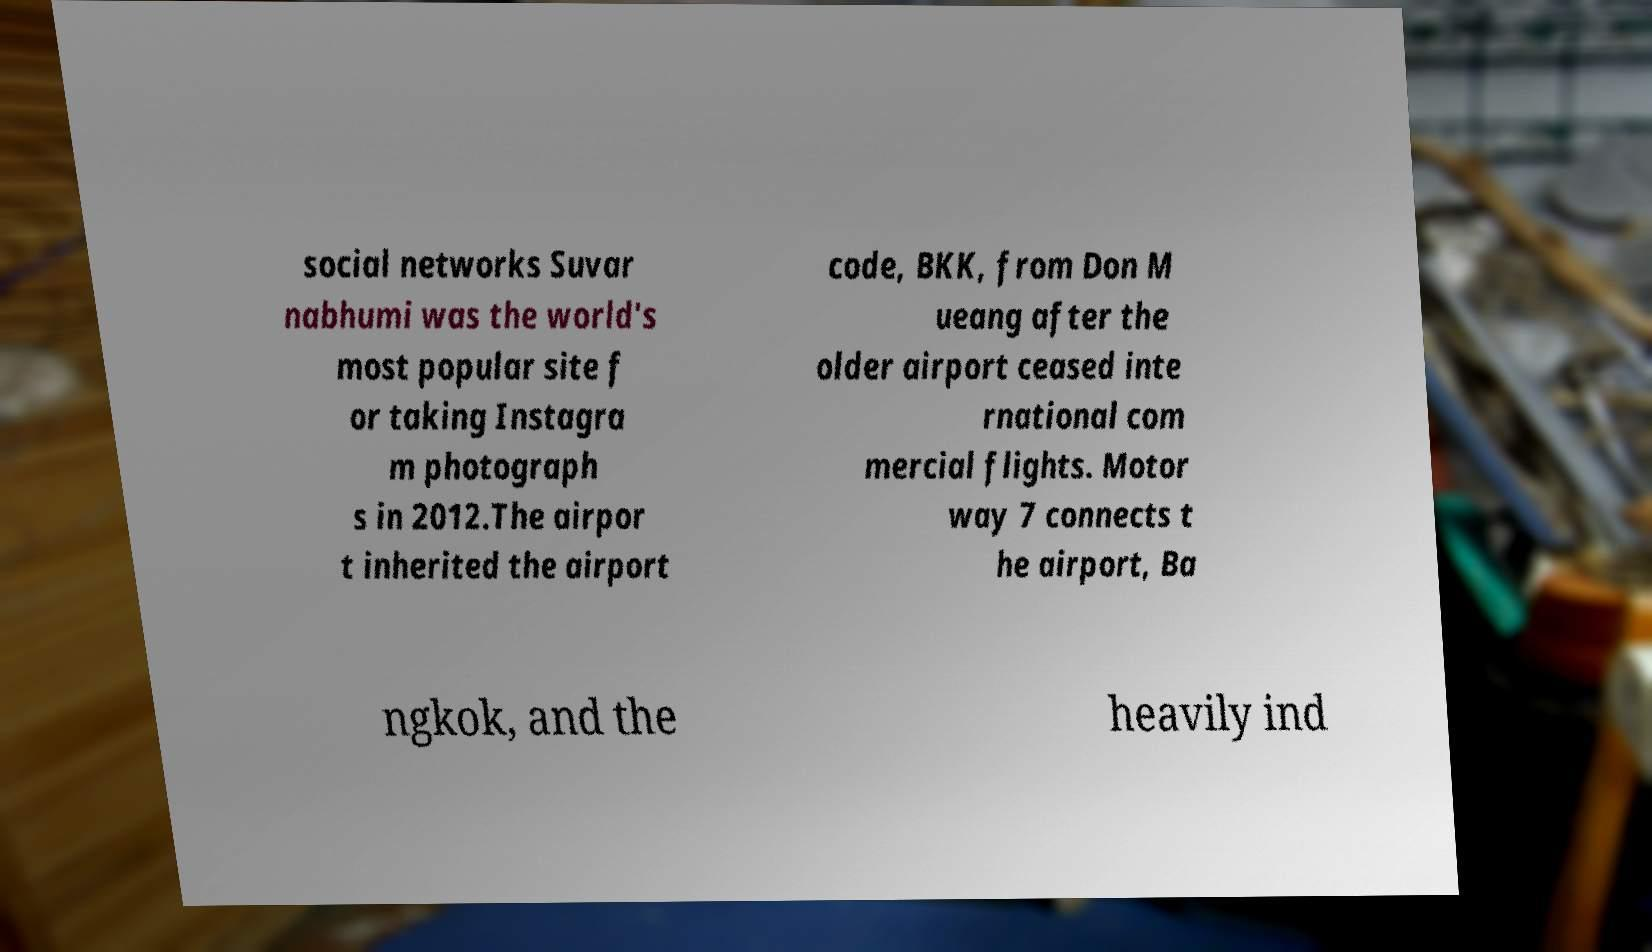What messages or text are displayed in this image? I need them in a readable, typed format. social networks Suvar nabhumi was the world's most popular site f or taking Instagra m photograph s in 2012.The airpor t inherited the airport code, BKK, from Don M ueang after the older airport ceased inte rnational com mercial flights. Motor way 7 connects t he airport, Ba ngkok, and the heavily ind 